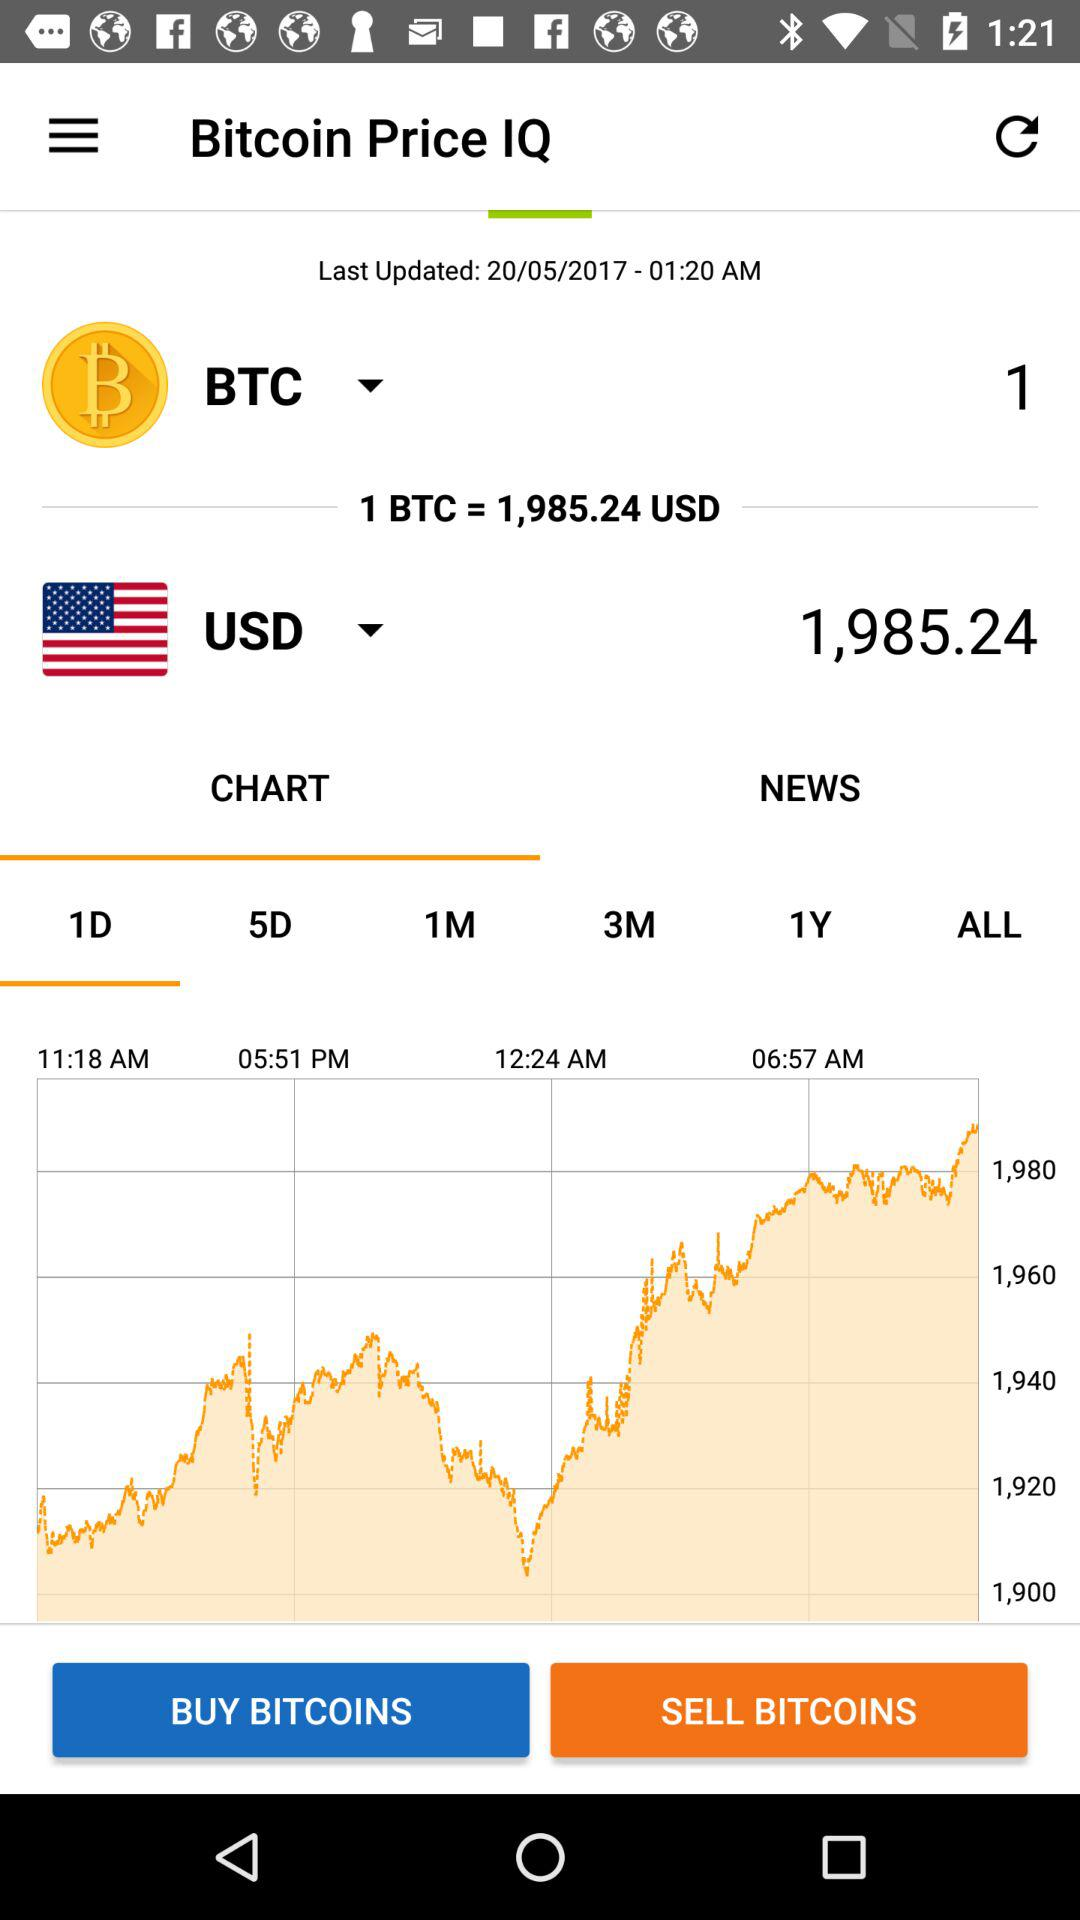Which day is selected in the chart? The selected day in the chart is 1. 